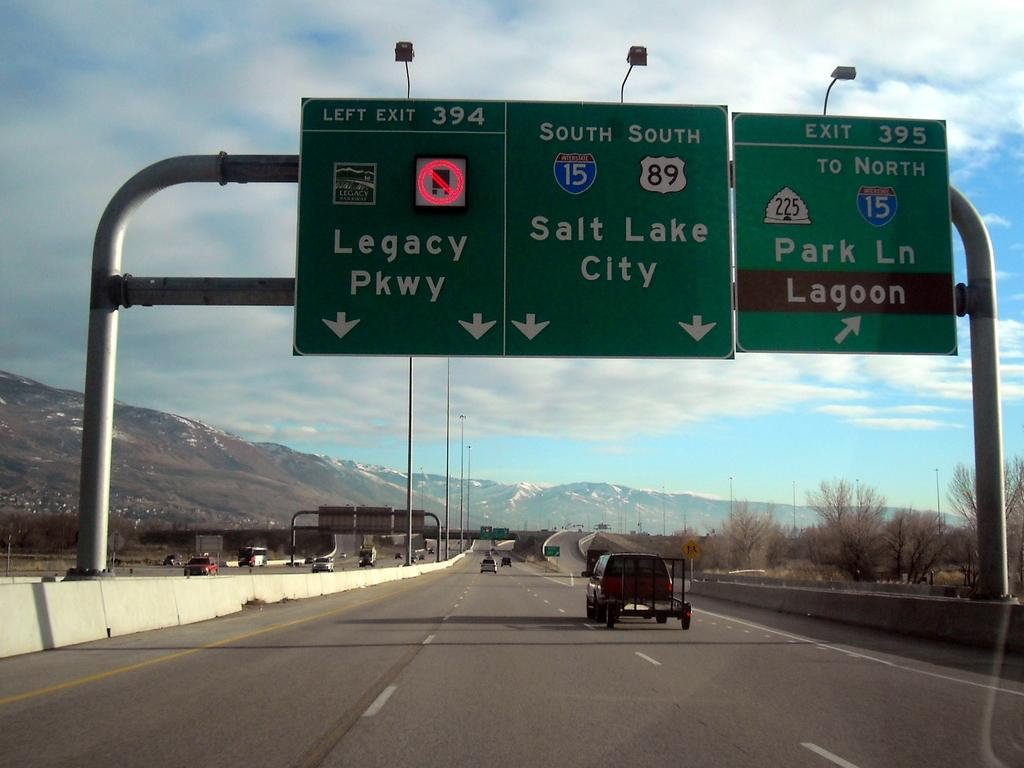Provide a one-sentence caption for the provided image. A large green street sign indicating which lane to be in for Legacy Parkway. 